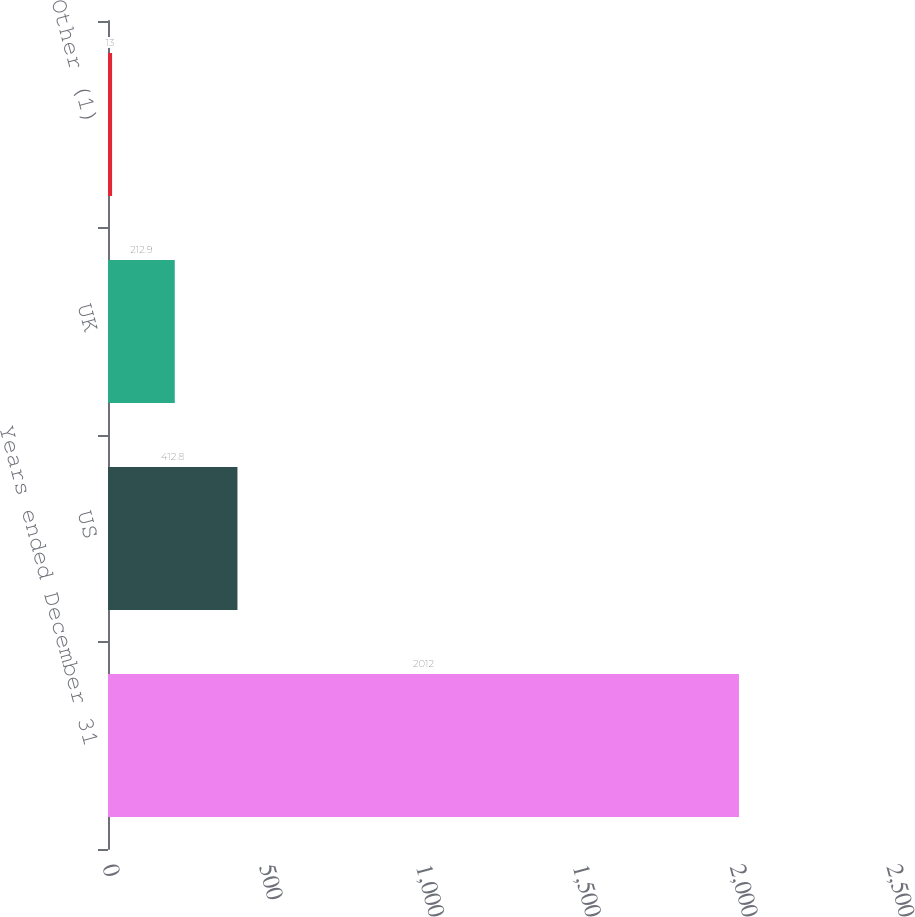<chart> <loc_0><loc_0><loc_500><loc_500><bar_chart><fcel>Years ended December 31<fcel>US<fcel>UK<fcel>Other (1)<nl><fcel>2012<fcel>412.8<fcel>212.9<fcel>13<nl></chart> 